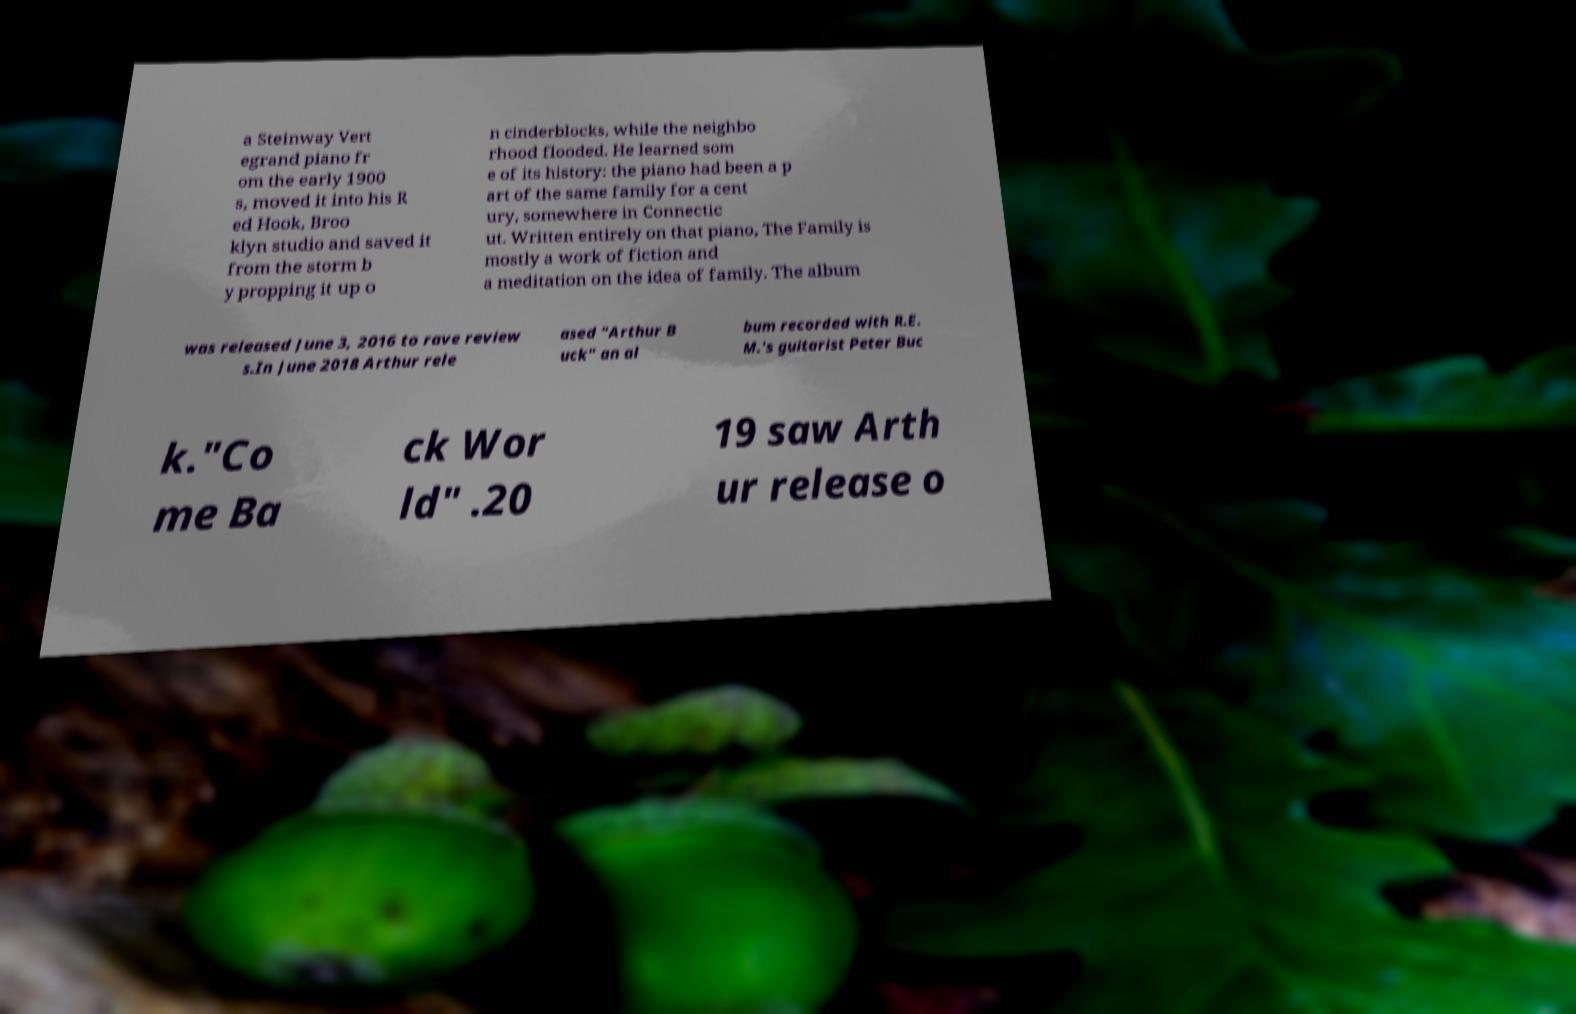Please identify and transcribe the text found in this image. a Steinway Vert egrand piano fr om the early 1900 s, moved it into his R ed Hook, Broo klyn studio and saved it from the storm b y propping it up o n cinderblocks, while the neighbo rhood flooded. He learned som e of its history: the piano had been a p art of the same family for a cent ury, somewhere in Connectic ut. Written entirely on that piano, The Family is mostly a work of fiction and a meditation on the idea of family. The album was released June 3, 2016 to rave review s.In June 2018 Arthur rele ased "Arthur B uck" an al bum recorded with R.E. M.'s guitarist Peter Buc k."Co me Ba ck Wor ld" .20 19 saw Arth ur release o 